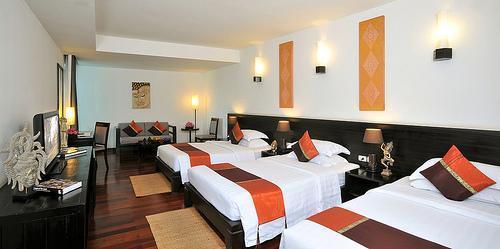How many beds are there?
Give a very brief answer. 3. 